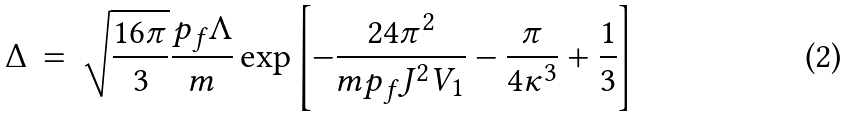<formula> <loc_0><loc_0><loc_500><loc_500>\Delta \, = \, \sqrt { \frac { 1 6 \pi } { 3 } } \frac { p _ { f } \Lambda } { m } \exp \left [ - \frac { 2 4 \pi ^ { 2 } } { m p _ { f } J ^ { 2 } V _ { 1 } } - \frac { \pi } { 4 \kappa ^ { 3 } } + \frac { 1 } { 3 } \right ]</formula> 